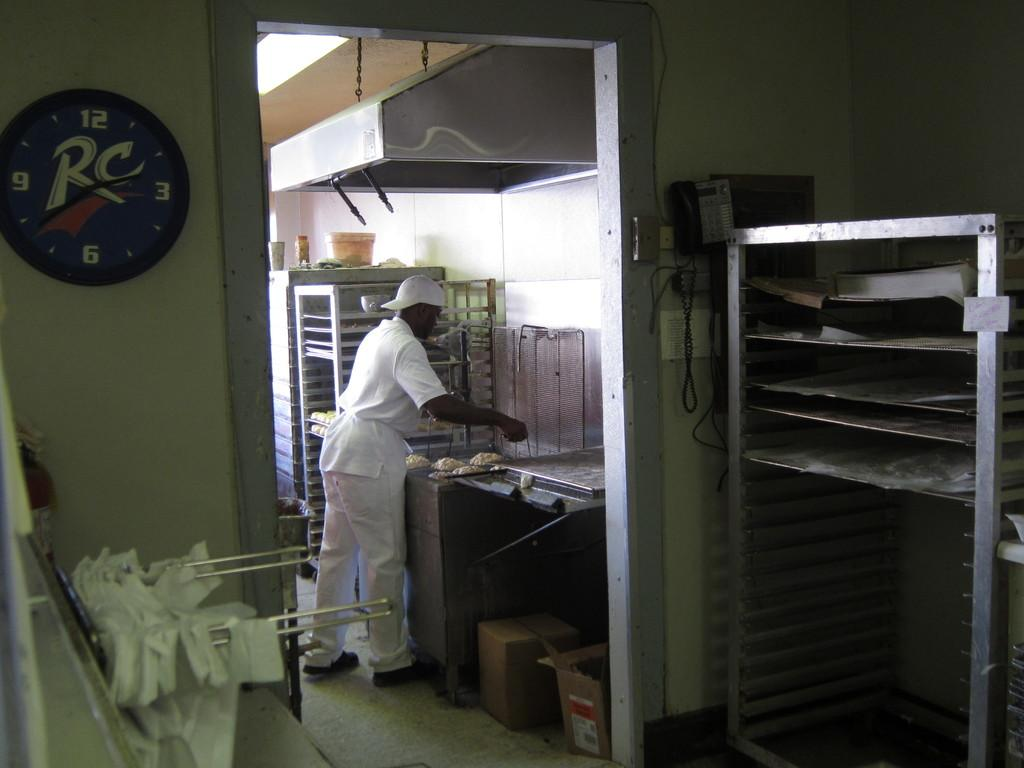<image>
Give a short and clear explanation of the subsequent image. A man working in a kitchen with a RC clock on the wall. 